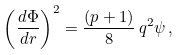<formula> <loc_0><loc_0><loc_500><loc_500>\left ( \frac { d \Phi } { d r } \right ) ^ { 2 } = \frac { ( p + 1 ) } { 8 } \, q ^ { 2 } \psi \, ,</formula> 